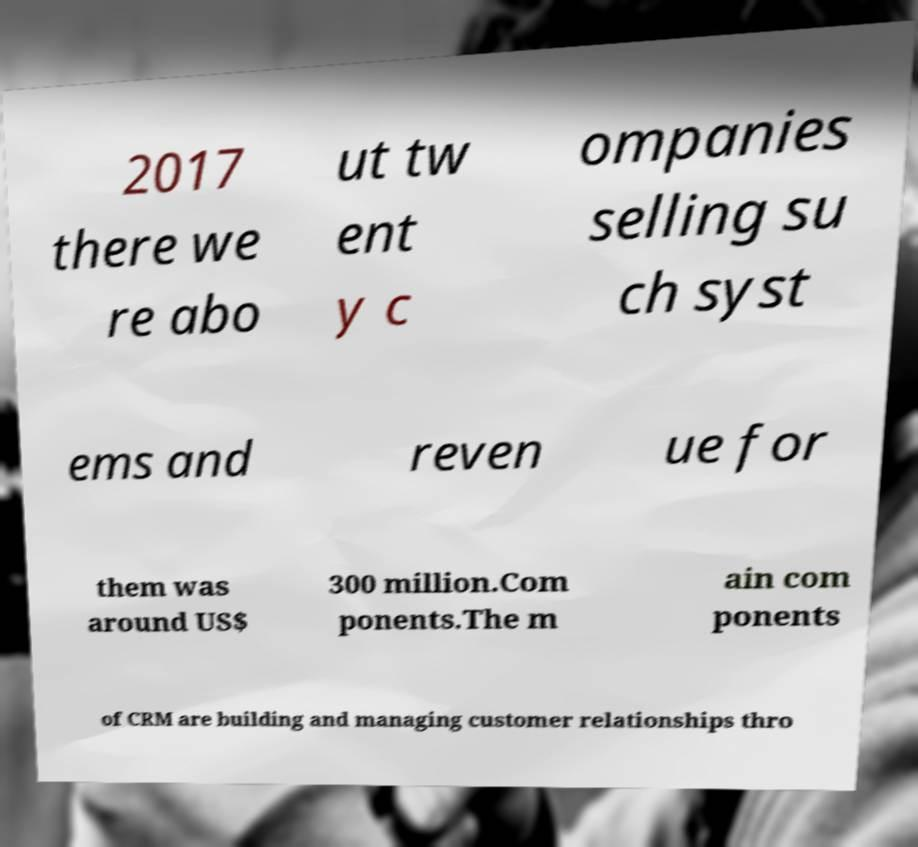Can you read and provide the text displayed in the image?This photo seems to have some interesting text. Can you extract and type it out for me? 2017 there we re abo ut tw ent y c ompanies selling su ch syst ems and reven ue for them was around US$ 300 million.Com ponents.The m ain com ponents of CRM are building and managing customer relationships thro 